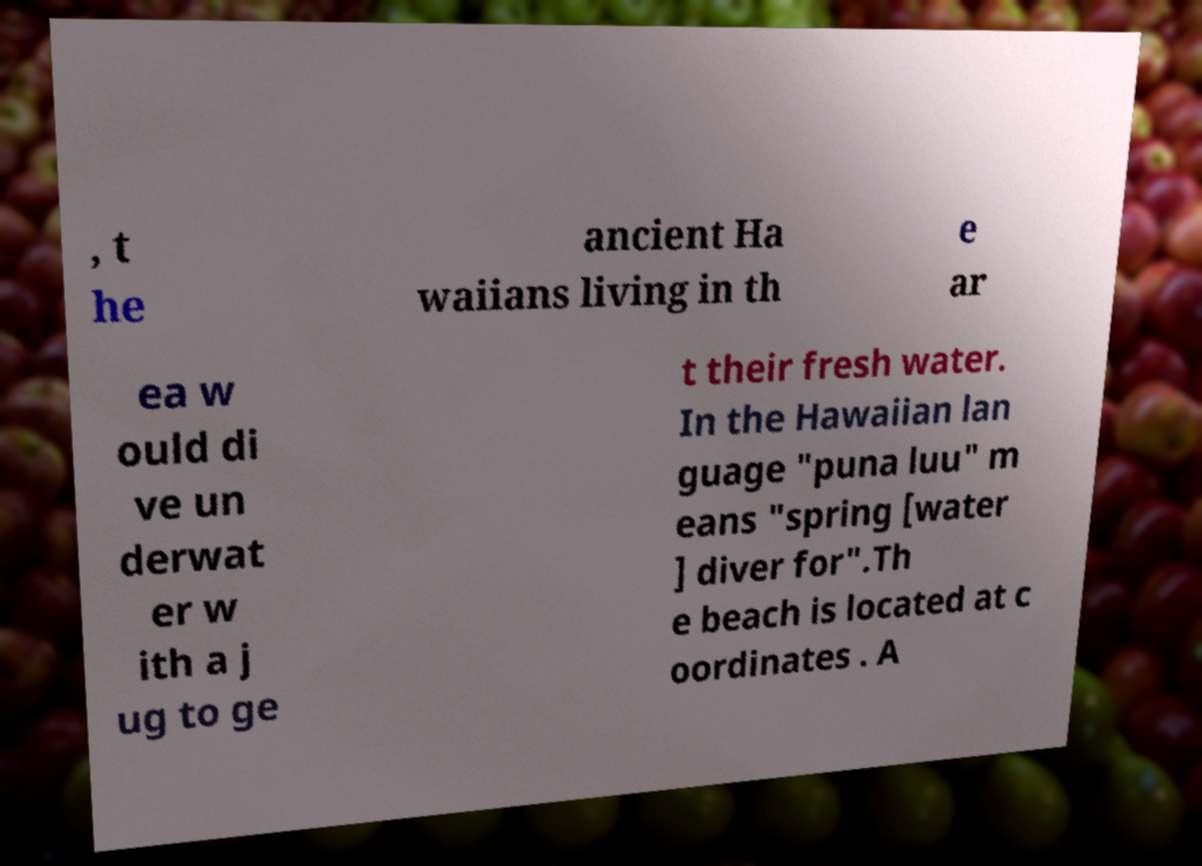For documentation purposes, I need the text within this image transcribed. Could you provide that? , t he ancient Ha waiians living in th e ar ea w ould di ve un derwat er w ith a j ug to ge t their fresh water. In the Hawaiian lan guage "puna luu" m eans "spring [water ] diver for".Th e beach is located at c oordinates . A 